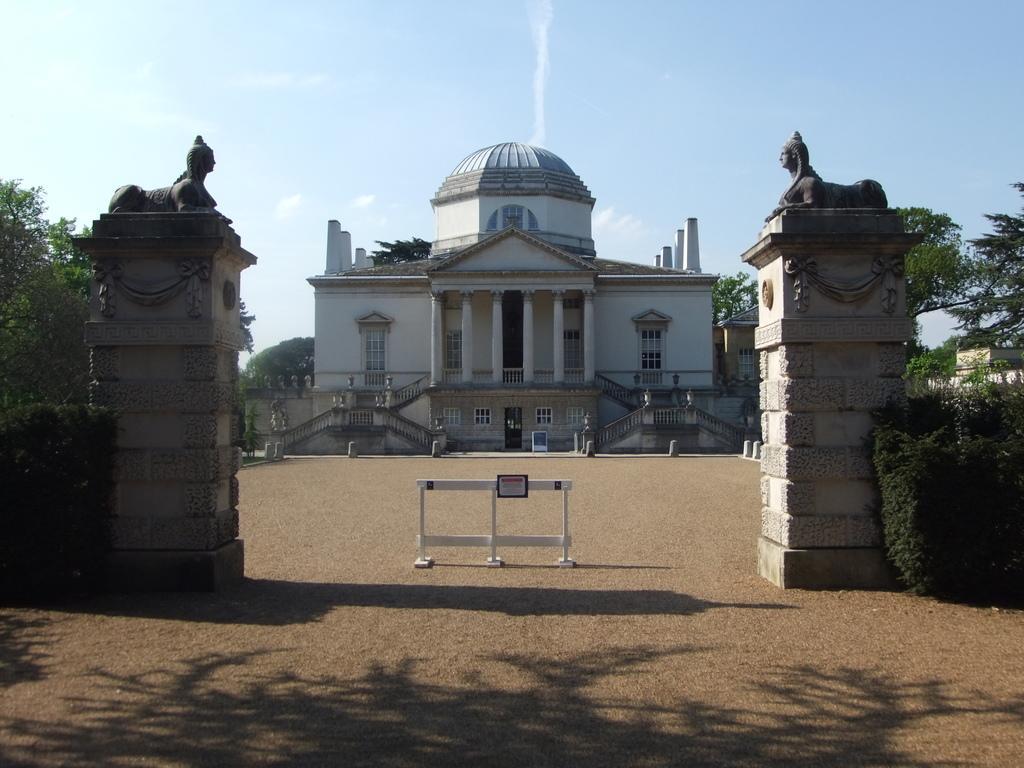Please provide a concise description of this image. In this image, there are two pillars, on that pillars there are two black color statues, at the middle there is a white color stand, at the background there is a house, there are some green color trees at the right and left side, at the top there is a blue color sky. 